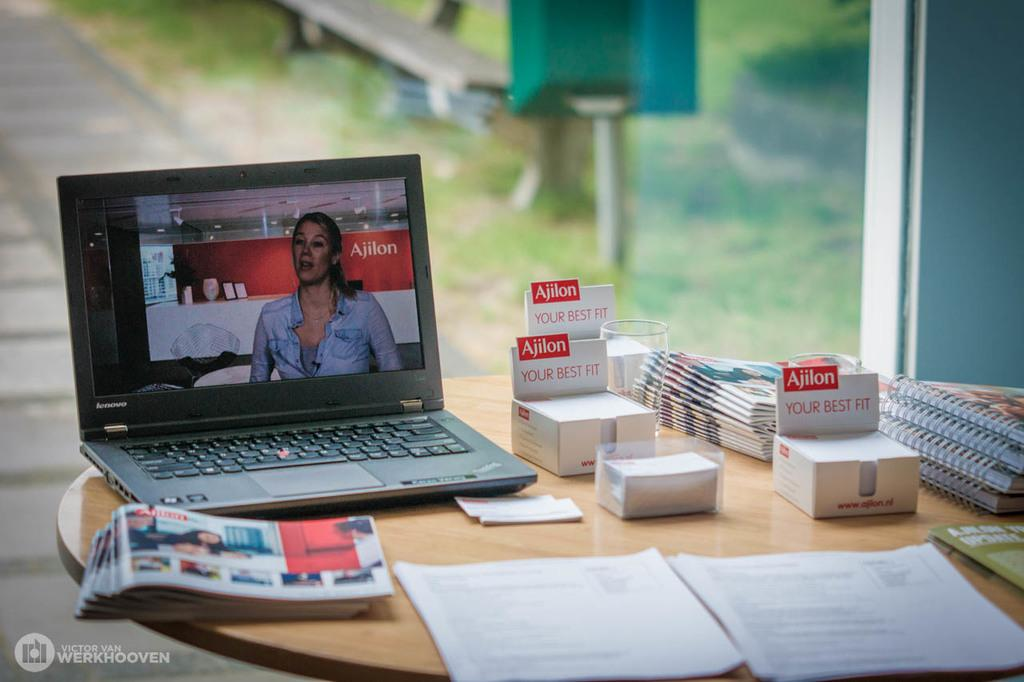What electronic device is on the table in the image? There is a laptop on the table in the image. What type of reading material is on the table? There are magazines on the table. What type of paper items are on the table? There are notes and visiting cards on the table. Can you describe any other items on the table? There are additional unspecified items on the table. What type of letter is being delivered by the flock of birds in the image? There is no flock of birds or letter present in the image. Who is wearing the crown in the image? There is no crown or person wearing a crown present in the image. 